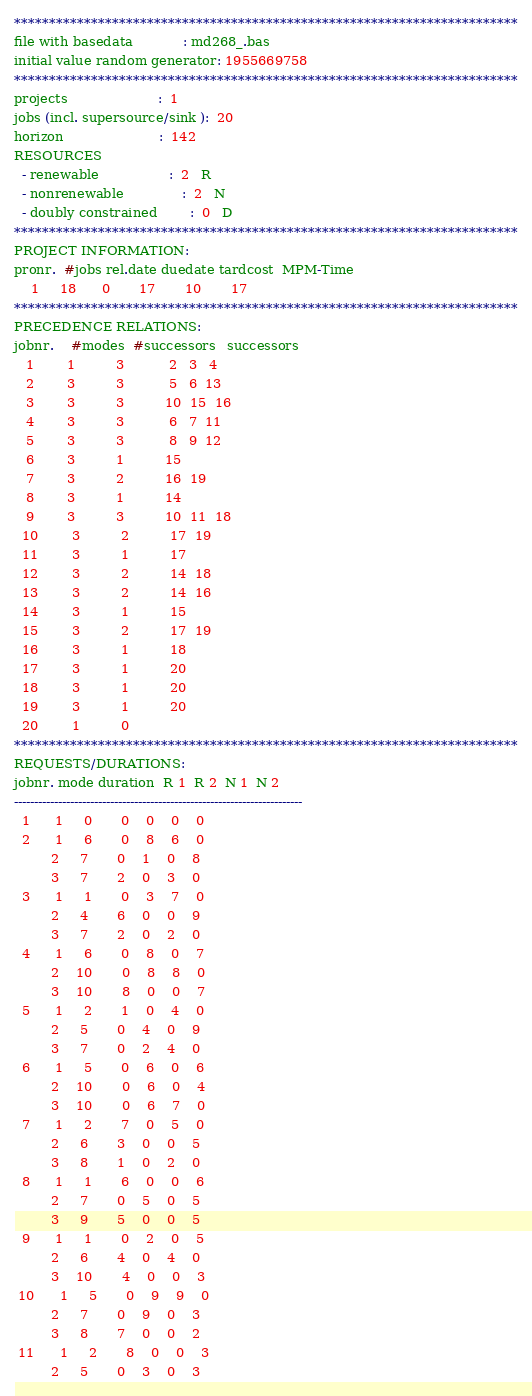Convert code to text. <code><loc_0><loc_0><loc_500><loc_500><_ObjectiveC_>************************************************************************
file with basedata            : md268_.bas
initial value random generator: 1955669758
************************************************************************
projects                      :  1
jobs (incl. supersource/sink ):  20
horizon                       :  142
RESOURCES
  - renewable                 :  2   R
  - nonrenewable              :  2   N
  - doubly constrained        :  0   D
************************************************************************
PROJECT INFORMATION:
pronr.  #jobs rel.date duedate tardcost  MPM-Time
    1     18      0       17       10       17
************************************************************************
PRECEDENCE RELATIONS:
jobnr.    #modes  #successors   successors
   1        1          3           2   3   4
   2        3          3           5   6  13
   3        3          3          10  15  16
   4        3          3           6   7  11
   5        3          3           8   9  12
   6        3          1          15
   7        3          2          16  19
   8        3          1          14
   9        3          3          10  11  18
  10        3          2          17  19
  11        3          1          17
  12        3          2          14  18
  13        3          2          14  16
  14        3          1          15
  15        3          2          17  19
  16        3          1          18
  17        3          1          20
  18        3          1          20
  19        3          1          20
  20        1          0        
************************************************************************
REQUESTS/DURATIONS:
jobnr. mode duration  R 1  R 2  N 1  N 2
------------------------------------------------------------------------
  1      1     0       0    0    0    0
  2      1     6       0    8    6    0
         2     7       0    1    0    8
         3     7       2    0    3    0
  3      1     1       0    3    7    0
         2     4       6    0    0    9
         3     7       2    0    2    0
  4      1     6       0    8    0    7
         2    10       0    8    8    0
         3    10       8    0    0    7
  5      1     2       1    0    4    0
         2     5       0    4    0    9
         3     7       0    2    4    0
  6      1     5       0    6    0    6
         2    10       0    6    0    4
         3    10       0    6    7    0
  7      1     2       7    0    5    0
         2     6       3    0    0    5
         3     8       1    0    2    0
  8      1     1       6    0    0    6
         2     7       0    5    0    5
         3     9       5    0    0    5
  9      1     1       0    2    0    5
         2     6       4    0    4    0
         3    10       4    0    0    3
 10      1     5       0    9    9    0
         2     7       0    9    0    3
         3     8       7    0    0    2
 11      1     2       8    0    0    3
         2     5       0    3    0    3</code> 